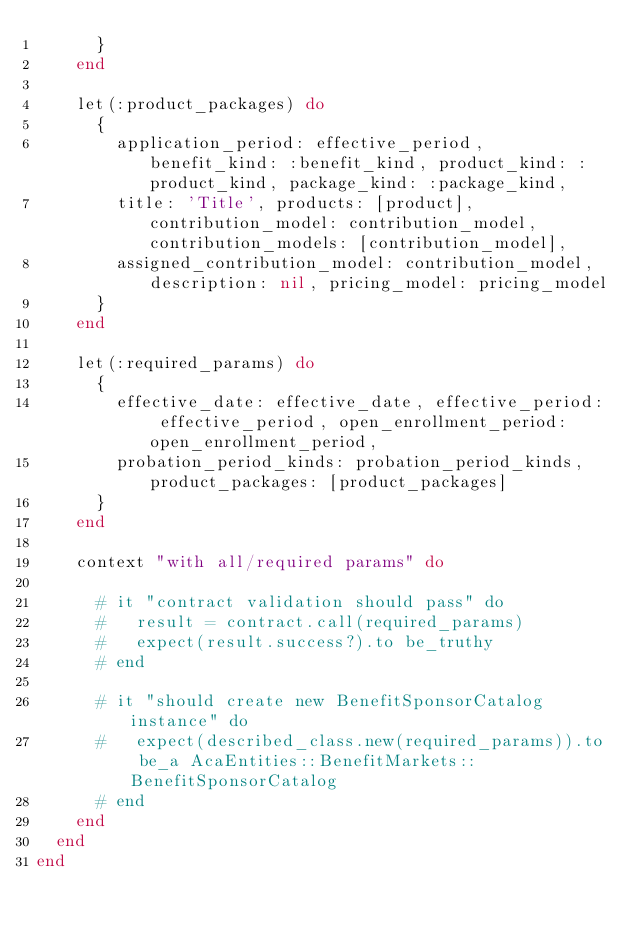Convert code to text. <code><loc_0><loc_0><loc_500><loc_500><_Ruby_>      }
    end

    let(:product_packages) do
      {
        application_period: effective_period, benefit_kind: :benefit_kind, product_kind: :product_kind, package_kind: :package_kind,
        title: 'Title', products: [product], contribution_model: contribution_model, contribution_models: [contribution_model],
        assigned_contribution_model: contribution_model, description: nil, pricing_model: pricing_model
      }
    end

    let(:required_params) do
      {
        effective_date: effective_date, effective_period: effective_period, open_enrollment_period: open_enrollment_period,
        probation_period_kinds: probation_period_kinds, product_packages: [product_packages]
      }
    end

    context "with all/required params" do

      # it "contract validation should pass" do
      #   result = contract.call(required_params)
      #   expect(result.success?).to be_truthy
      # end

      # it "should create new BenefitSponsorCatalog instance" do
      #   expect(described_class.new(required_params)).to be_a AcaEntities::BenefitMarkets::BenefitSponsorCatalog
      # end
    end
  end
end
</code> 